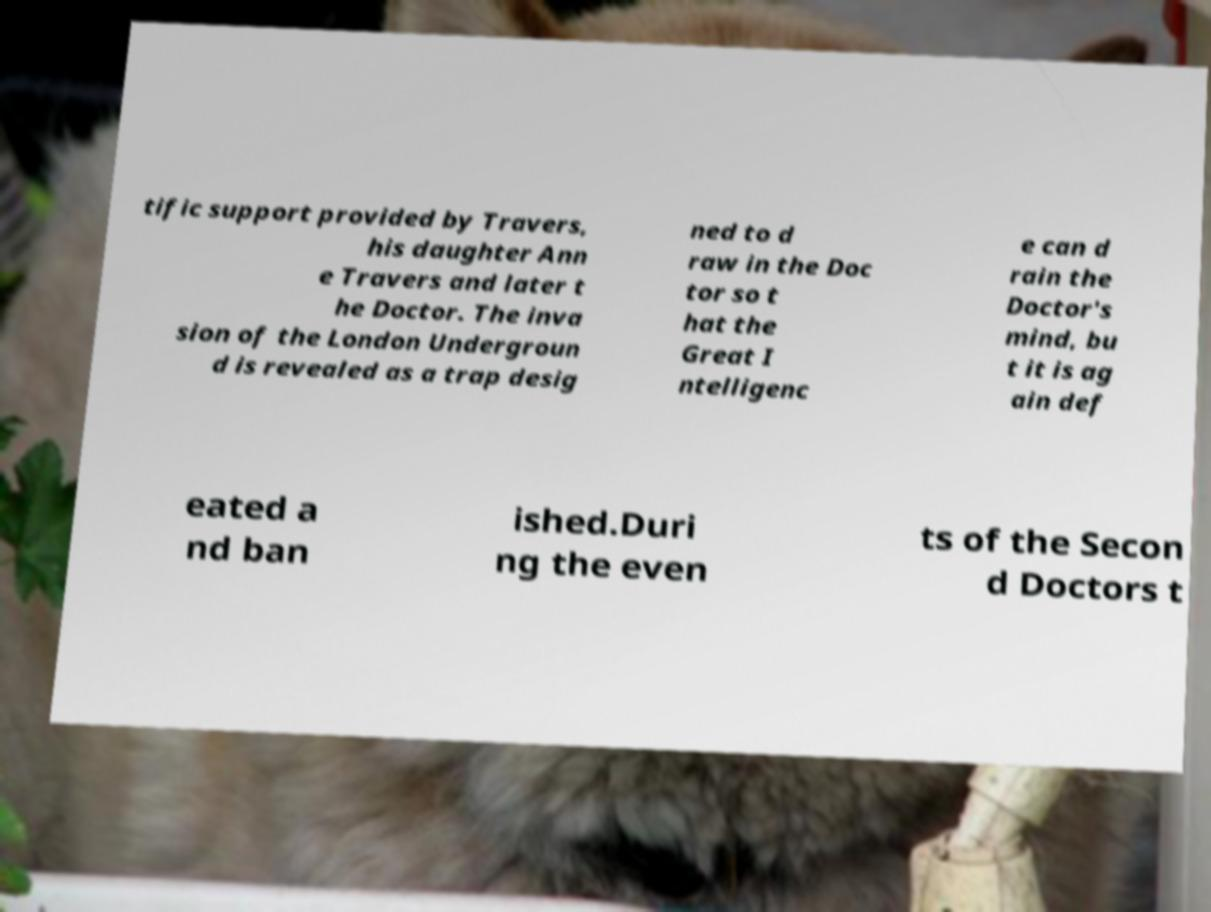Could you extract and type out the text from this image? tific support provided by Travers, his daughter Ann e Travers and later t he Doctor. The inva sion of the London Undergroun d is revealed as a trap desig ned to d raw in the Doc tor so t hat the Great I ntelligenc e can d rain the Doctor's mind, bu t it is ag ain def eated a nd ban ished.Duri ng the even ts of the Secon d Doctors t 